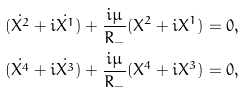Convert formula to latex. <formula><loc_0><loc_0><loc_500><loc_500>( \dot { X ^ { 2 } } + i \dot { X ^ { 1 } } ) + \frac { i \mu } { R _ { - } } ( X ^ { 2 } + i X ^ { 1 } ) = 0 , \\ ( \dot { X ^ { 4 } } + i \dot { X ^ { 3 } } ) + \frac { i \mu } { R _ { - } } ( X ^ { 4 } + i X ^ { 3 } ) = 0 ,</formula> 